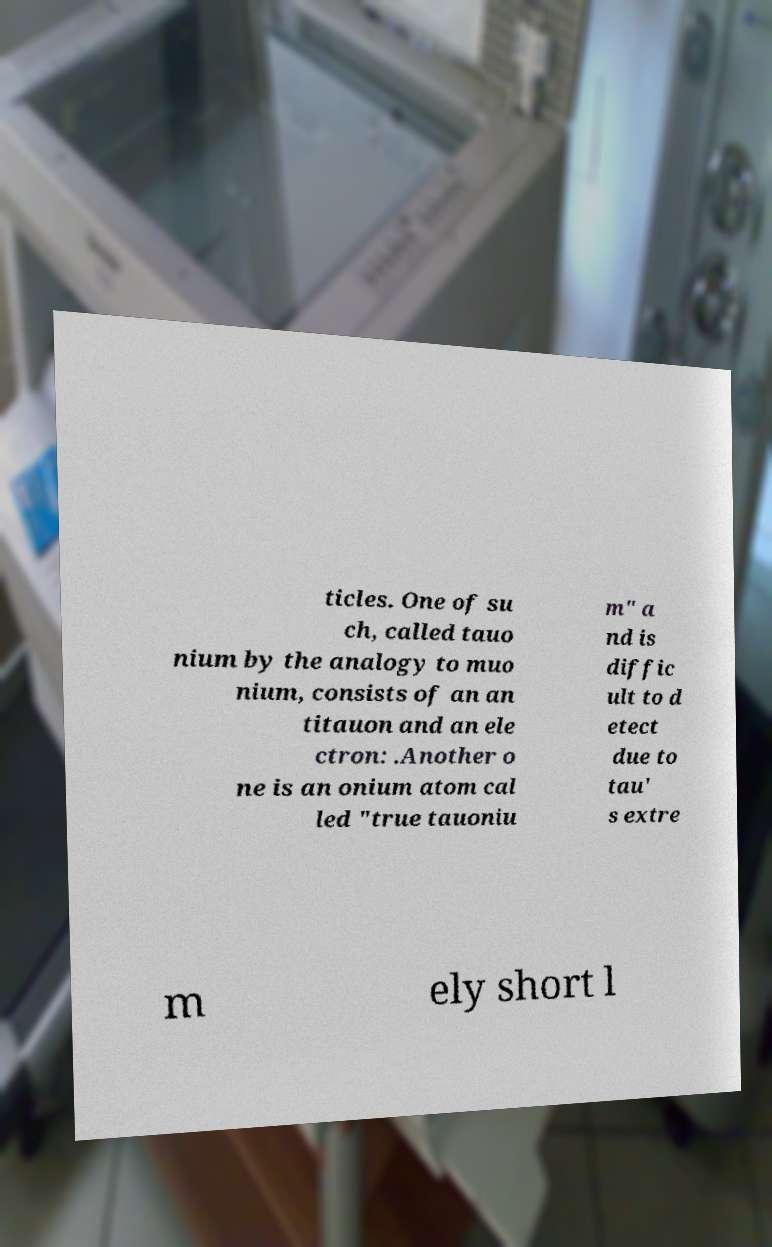Please identify and transcribe the text found in this image. ticles. One of su ch, called tauo nium by the analogy to muo nium, consists of an an titauon and an ele ctron: .Another o ne is an onium atom cal led "true tauoniu m" a nd is diffic ult to d etect due to tau' s extre m ely short l 